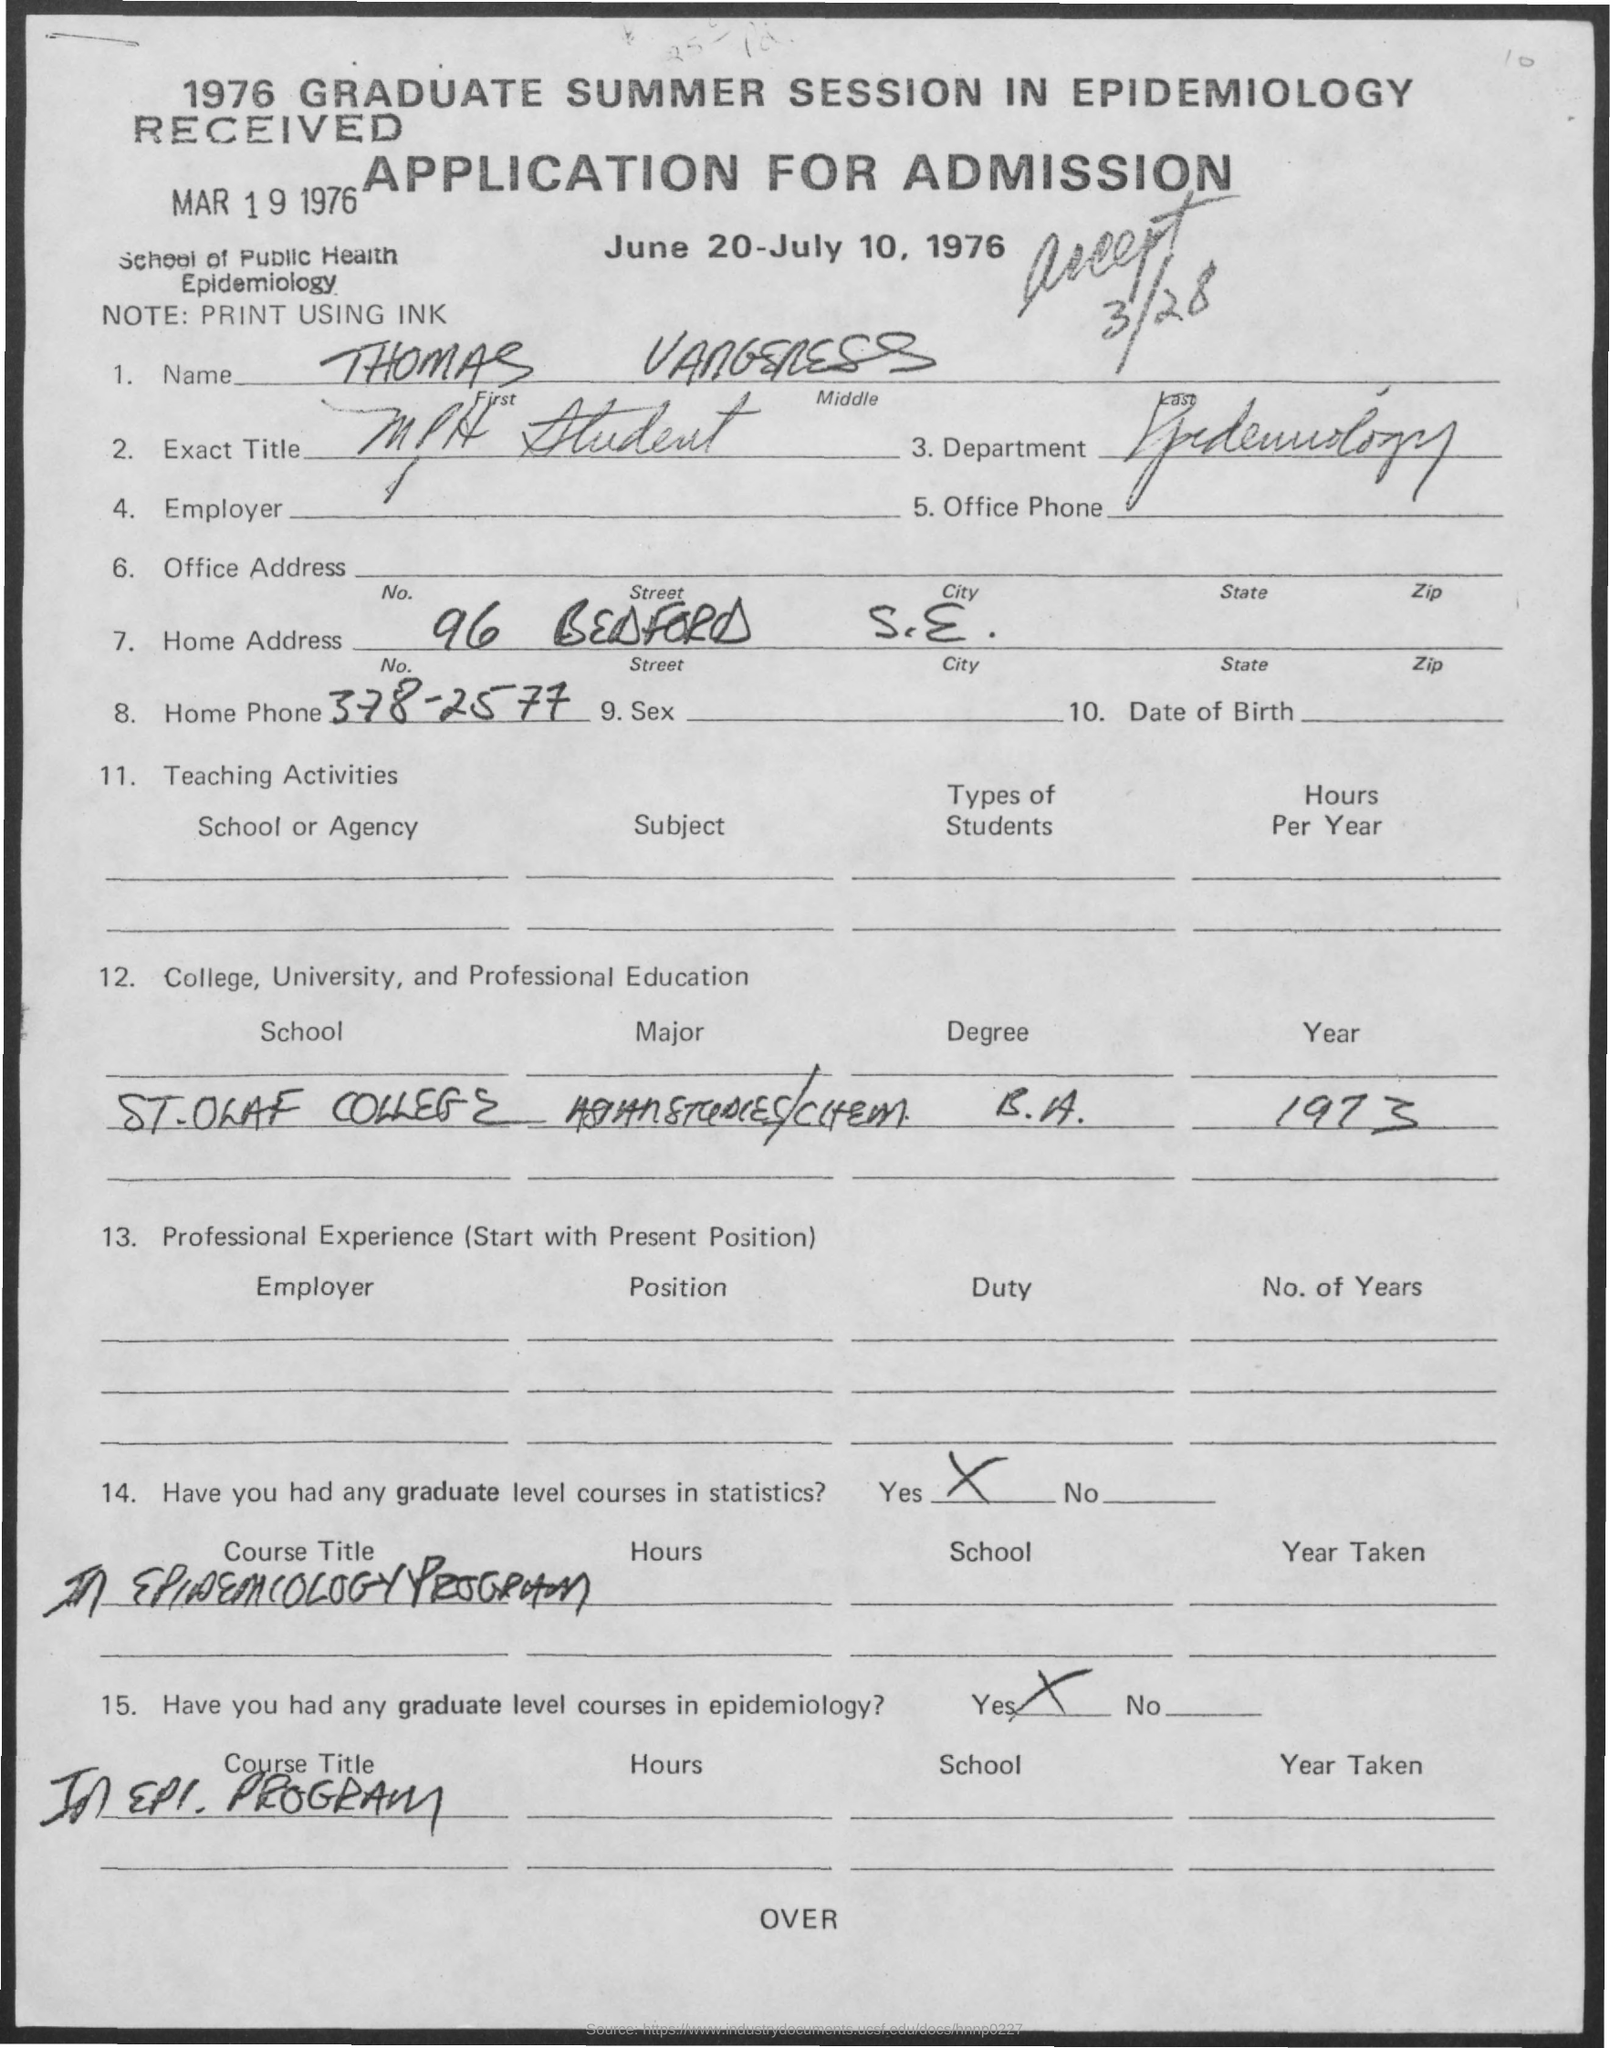Point out several critical features in this image. The phone number "378-2577" is a home phone. The person's first name is Thomas. In 1973, the subject was a student at St. Olaf College. The department is epidemiology. 